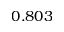<formula> <loc_0><loc_0><loc_500><loc_500>0 . 8 0 3</formula> 